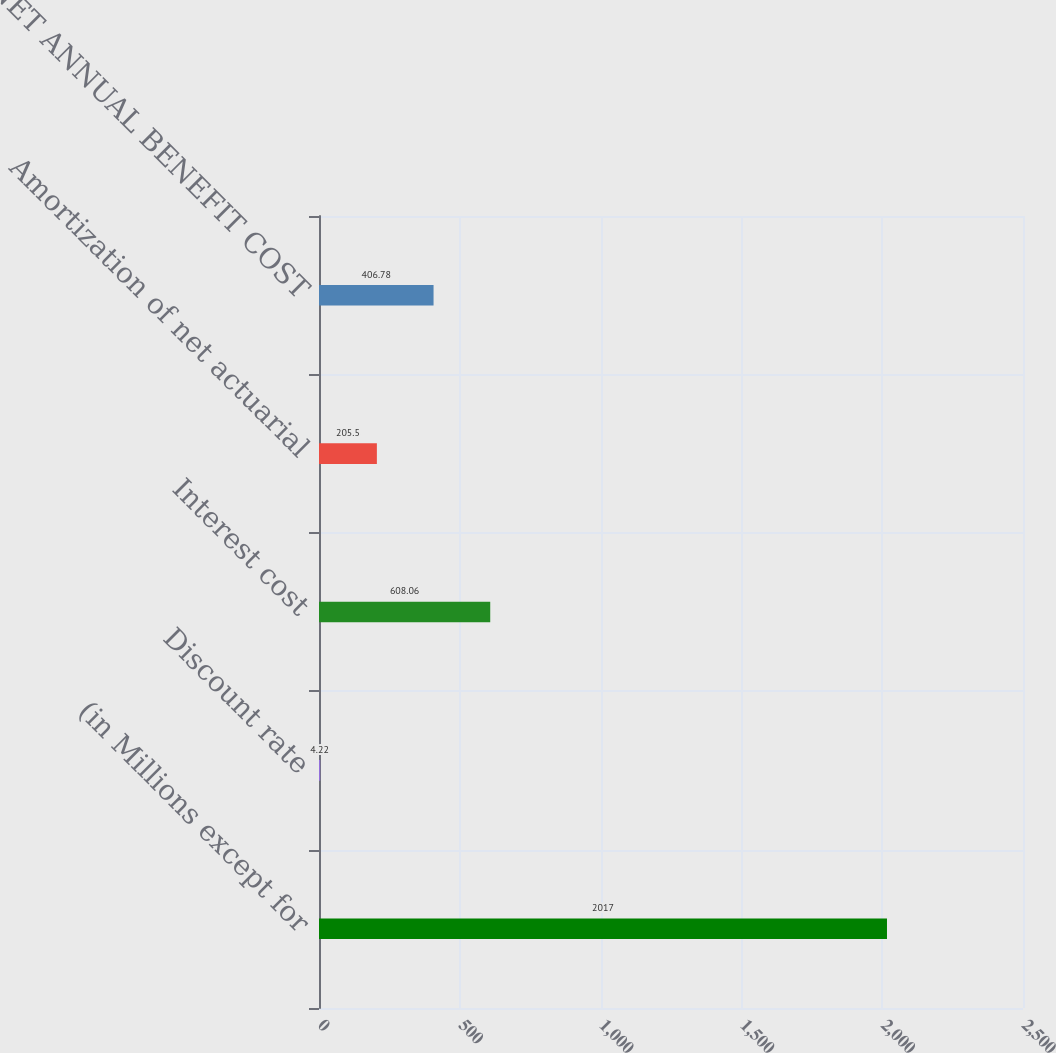<chart> <loc_0><loc_0><loc_500><loc_500><bar_chart><fcel>(in Millions except for<fcel>Discount rate<fcel>Interest cost<fcel>Amortization of net actuarial<fcel>NET ANNUAL BENEFIT COST<nl><fcel>2017<fcel>4.22<fcel>608.06<fcel>205.5<fcel>406.78<nl></chart> 